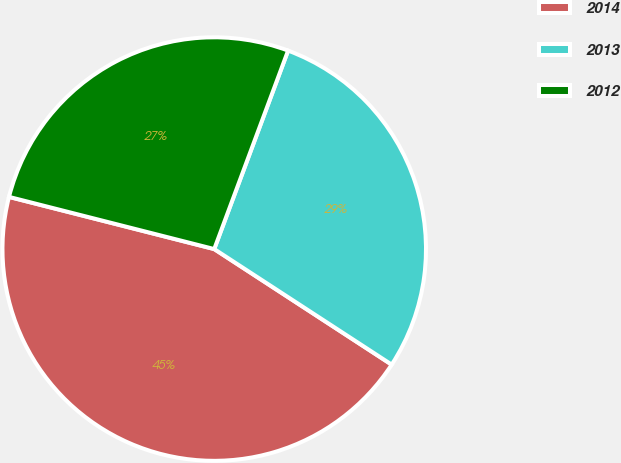Convert chart to OTSL. <chart><loc_0><loc_0><loc_500><loc_500><pie_chart><fcel>2014<fcel>2013<fcel>2012<nl><fcel>44.78%<fcel>28.52%<fcel>26.71%<nl></chart> 